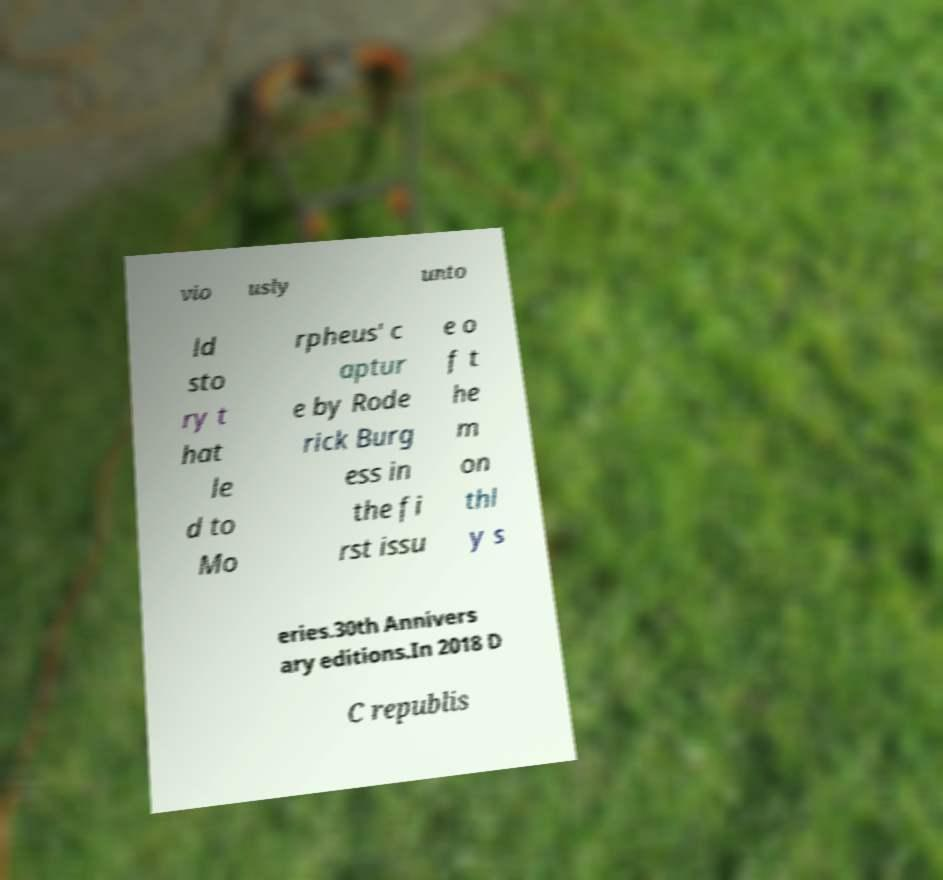For documentation purposes, I need the text within this image transcribed. Could you provide that? vio usly unto ld sto ry t hat le d to Mo rpheus' c aptur e by Rode rick Burg ess in the fi rst issu e o f t he m on thl y s eries.30th Annivers ary editions.In 2018 D C republis 